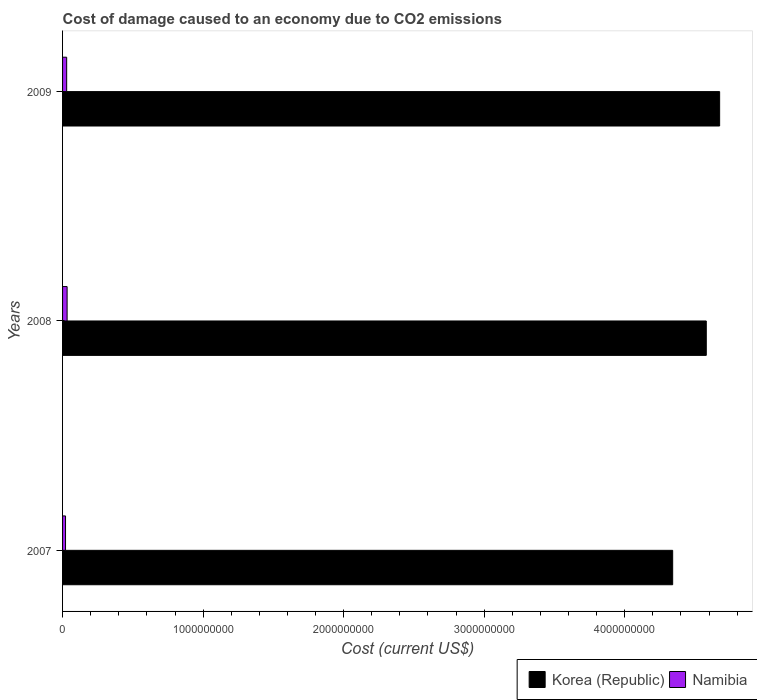How many different coloured bars are there?
Your response must be concise. 2. Are the number of bars per tick equal to the number of legend labels?
Your answer should be compact. Yes. What is the cost of damage caused due to CO2 emissisons in Korea (Republic) in 2009?
Your answer should be very brief. 4.68e+09. Across all years, what is the maximum cost of damage caused due to CO2 emissisons in Namibia?
Your answer should be compact. 3.23e+07. Across all years, what is the minimum cost of damage caused due to CO2 emissisons in Korea (Republic)?
Offer a terse response. 4.34e+09. What is the total cost of damage caused due to CO2 emissisons in Korea (Republic) in the graph?
Provide a short and direct response. 1.36e+1. What is the difference between the cost of damage caused due to CO2 emissisons in Korea (Republic) in 2007 and that in 2008?
Keep it short and to the point. -2.39e+08. What is the difference between the cost of damage caused due to CO2 emissisons in Korea (Republic) in 2009 and the cost of damage caused due to CO2 emissisons in Namibia in 2008?
Your response must be concise. 4.64e+09. What is the average cost of damage caused due to CO2 emissisons in Korea (Republic) per year?
Your answer should be very brief. 4.53e+09. In the year 2008, what is the difference between the cost of damage caused due to CO2 emissisons in Korea (Republic) and cost of damage caused due to CO2 emissisons in Namibia?
Keep it short and to the point. 4.55e+09. What is the ratio of the cost of damage caused due to CO2 emissisons in Namibia in 2007 to that in 2008?
Ensure brevity in your answer.  0.65. Is the cost of damage caused due to CO2 emissisons in Namibia in 2007 less than that in 2009?
Your answer should be compact. Yes. Is the difference between the cost of damage caused due to CO2 emissisons in Korea (Republic) in 2008 and 2009 greater than the difference between the cost of damage caused due to CO2 emissisons in Namibia in 2008 and 2009?
Make the answer very short. No. What is the difference between the highest and the second highest cost of damage caused due to CO2 emissisons in Korea (Republic)?
Offer a terse response. 9.50e+07. What is the difference between the highest and the lowest cost of damage caused due to CO2 emissisons in Korea (Republic)?
Offer a terse response. 3.34e+08. What does the 2nd bar from the top in 2008 represents?
Provide a succinct answer. Korea (Republic). What does the 2nd bar from the bottom in 2008 represents?
Offer a terse response. Namibia. Are all the bars in the graph horizontal?
Give a very brief answer. Yes. What is the difference between two consecutive major ticks on the X-axis?
Give a very brief answer. 1.00e+09. Are the values on the major ticks of X-axis written in scientific E-notation?
Keep it short and to the point. No. Where does the legend appear in the graph?
Keep it short and to the point. Bottom right. How many legend labels are there?
Offer a very short reply. 2. What is the title of the graph?
Your response must be concise. Cost of damage caused to an economy due to CO2 emissions. Does "Iran" appear as one of the legend labels in the graph?
Provide a short and direct response. No. What is the label or title of the X-axis?
Give a very brief answer. Cost (current US$). What is the Cost (current US$) of Korea (Republic) in 2007?
Your answer should be very brief. 4.34e+09. What is the Cost (current US$) in Namibia in 2007?
Your response must be concise. 2.11e+07. What is the Cost (current US$) of Korea (Republic) in 2008?
Provide a succinct answer. 4.58e+09. What is the Cost (current US$) of Namibia in 2008?
Ensure brevity in your answer.  3.23e+07. What is the Cost (current US$) of Korea (Republic) in 2009?
Offer a very short reply. 4.68e+09. What is the Cost (current US$) of Namibia in 2009?
Keep it short and to the point. 2.92e+07. Across all years, what is the maximum Cost (current US$) in Korea (Republic)?
Make the answer very short. 4.68e+09. Across all years, what is the maximum Cost (current US$) in Namibia?
Provide a short and direct response. 3.23e+07. Across all years, what is the minimum Cost (current US$) in Korea (Republic)?
Your response must be concise. 4.34e+09. Across all years, what is the minimum Cost (current US$) in Namibia?
Offer a very short reply. 2.11e+07. What is the total Cost (current US$) of Korea (Republic) in the graph?
Your answer should be compact. 1.36e+1. What is the total Cost (current US$) in Namibia in the graph?
Your answer should be compact. 8.26e+07. What is the difference between the Cost (current US$) of Korea (Republic) in 2007 and that in 2008?
Give a very brief answer. -2.39e+08. What is the difference between the Cost (current US$) of Namibia in 2007 and that in 2008?
Your answer should be compact. -1.12e+07. What is the difference between the Cost (current US$) of Korea (Republic) in 2007 and that in 2009?
Offer a terse response. -3.34e+08. What is the difference between the Cost (current US$) in Namibia in 2007 and that in 2009?
Your response must be concise. -8.14e+06. What is the difference between the Cost (current US$) in Korea (Republic) in 2008 and that in 2009?
Your answer should be very brief. -9.50e+07. What is the difference between the Cost (current US$) of Namibia in 2008 and that in 2009?
Offer a terse response. 3.05e+06. What is the difference between the Cost (current US$) in Korea (Republic) in 2007 and the Cost (current US$) in Namibia in 2008?
Offer a very short reply. 4.31e+09. What is the difference between the Cost (current US$) in Korea (Republic) in 2007 and the Cost (current US$) in Namibia in 2009?
Your answer should be very brief. 4.31e+09. What is the difference between the Cost (current US$) of Korea (Republic) in 2008 and the Cost (current US$) of Namibia in 2009?
Provide a short and direct response. 4.55e+09. What is the average Cost (current US$) of Korea (Republic) per year?
Give a very brief answer. 4.53e+09. What is the average Cost (current US$) in Namibia per year?
Your response must be concise. 2.75e+07. In the year 2007, what is the difference between the Cost (current US$) in Korea (Republic) and Cost (current US$) in Namibia?
Provide a short and direct response. 4.32e+09. In the year 2008, what is the difference between the Cost (current US$) in Korea (Republic) and Cost (current US$) in Namibia?
Provide a short and direct response. 4.55e+09. In the year 2009, what is the difference between the Cost (current US$) in Korea (Republic) and Cost (current US$) in Namibia?
Ensure brevity in your answer.  4.65e+09. What is the ratio of the Cost (current US$) in Korea (Republic) in 2007 to that in 2008?
Keep it short and to the point. 0.95. What is the ratio of the Cost (current US$) of Namibia in 2007 to that in 2008?
Offer a terse response. 0.65. What is the ratio of the Cost (current US$) in Korea (Republic) in 2007 to that in 2009?
Make the answer very short. 0.93. What is the ratio of the Cost (current US$) in Namibia in 2007 to that in 2009?
Offer a terse response. 0.72. What is the ratio of the Cost (current US$) of Korea (Republic) in 2008 to that in 2009?
Provide a succinct answer. 0.98. What is the ratio of the Cost (current US$) of Namibia in 2008 to that in 2009?
Your answer should be very brief. 1.1. What is the difference between the highest and the second highest Cost (current US$) of Korea (Republic)?
Your answer should be very brief. 9.50e+07. What is the difference between the highest and the second highest Cost (current US$) of Namibia?
Offer a terse response. 3.05e+06. What is the difference between the highest and the lowest Cost (current US$) of Korea (Republic)?
Offer a terse response. 3.34e+08. What is the difference between the highest and the lowest Cost (current US$) in Namibia?
Ensure brevity in your answer.  1.12e+07. 